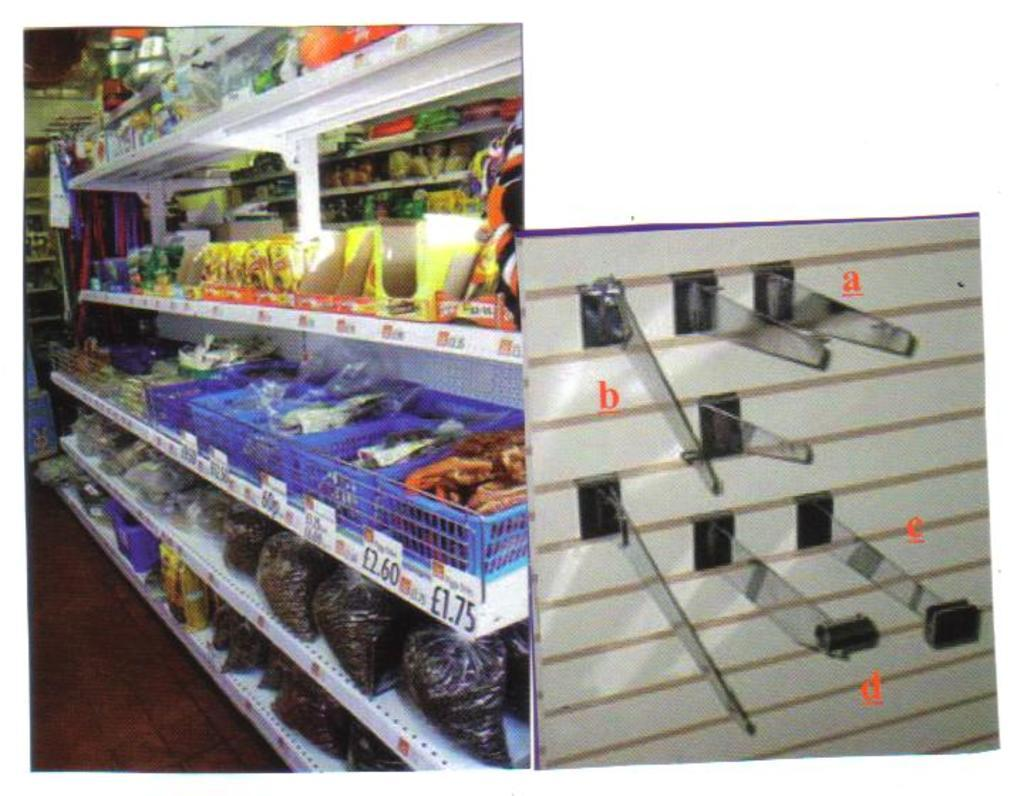Provide a one-sentence caption for the provided image. A basket of snacks can be purchased for 1.75 euros a piece. 